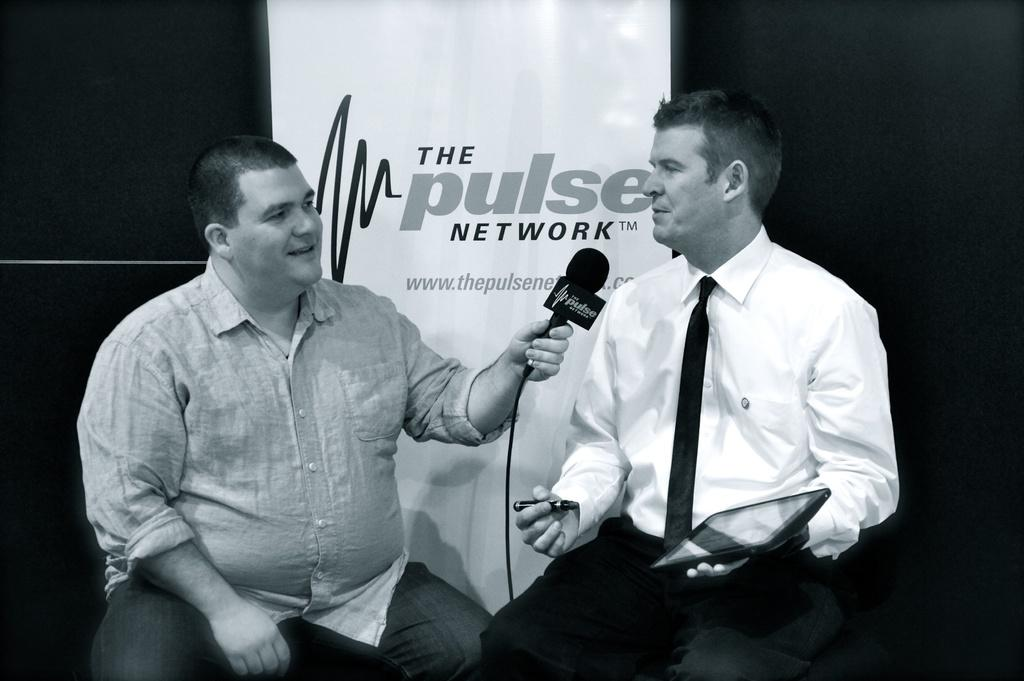How many people are in the image? There are two men in the image. What is one of the men holding? One of the men is holding a mic. What is the other man holding? The other man is holding an electronic device and a marker. What can be seen in the background of the image? There is a board visible in the background of the image. What type of sail is the grandfather using in the image? There is no grandfather or sail present in the image. What type of store is visible in the background of the image? There is no store visible in the background of the image; only a board can be seen. 